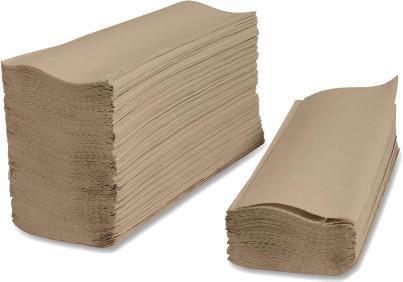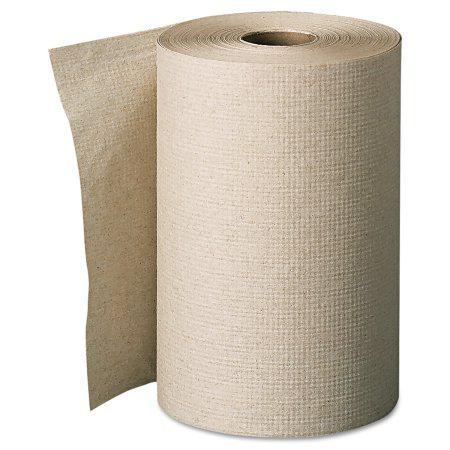The first image is the image on the left, the second image is the image on the right. Given the left and right images, does the statement "One of the images shows folded paper towels." hold true? Answer yes or no. Yes. The first image is the image on the left, the second image is the image on the right. Given the left and right images, does the statement "one of the images contains two stacks of paper towels." hold true? Answer yes or no. Yes. 